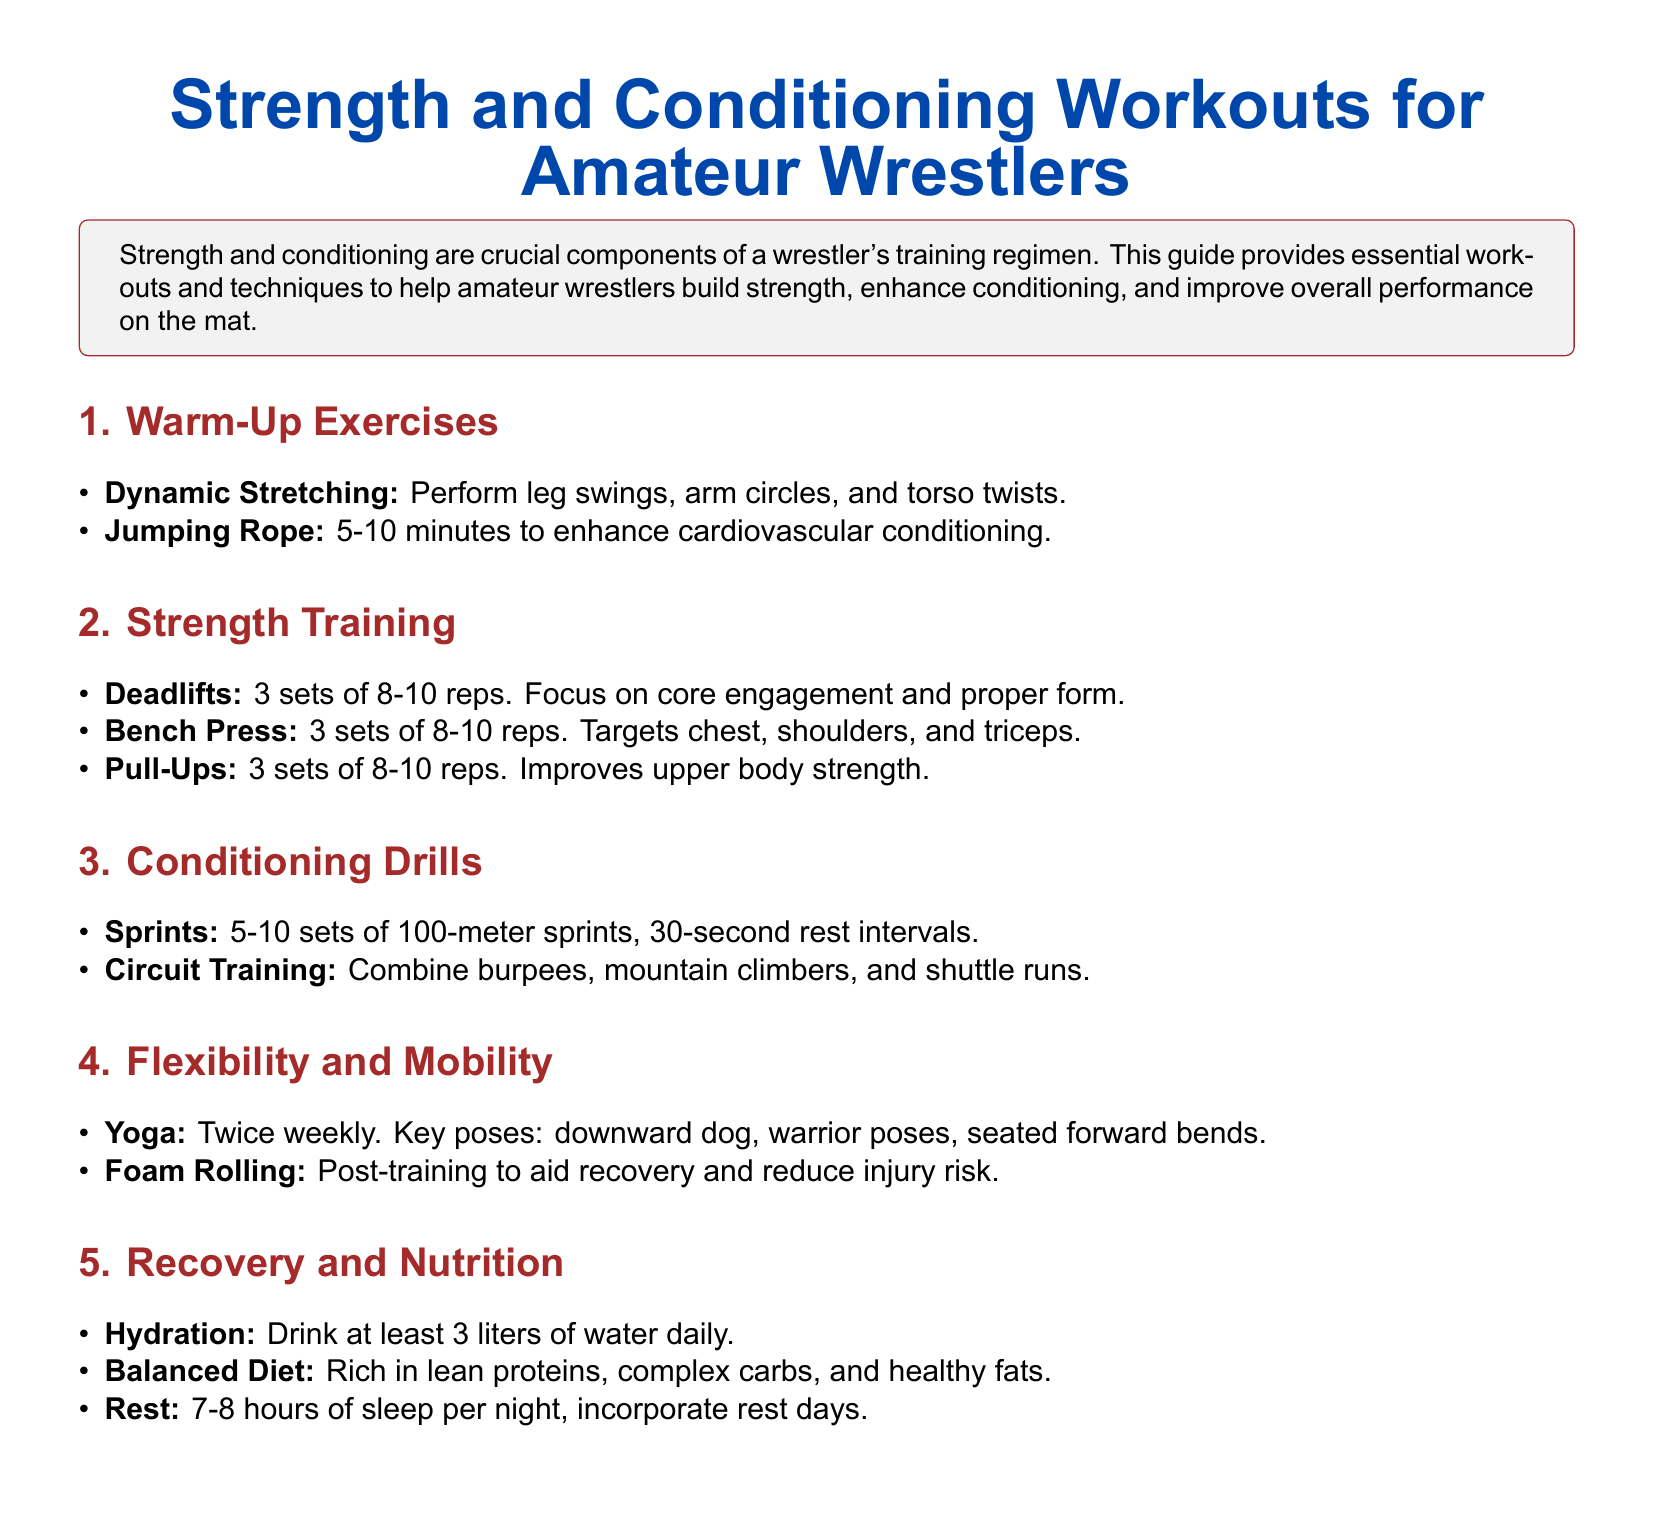What is the focus of warm-up exercises? The document states that warm-up exercises include dynamic stretching and jumping rope, enhancing cardiovascular conditioning and preparing the body for training.
Answer: dynamic stretching, jumping rope How many sets of deadlifts are recommended? The document specifies that the deadlifts exercise includes performing 3 sets of 8-10 reps.
Answer: 3 sets What conditioning drill involves sprints? The document mentions sprints as one of the conditioning drills, specifying sets and rest intervals.
Answer: sprints How often should yoga be performed according to the guide? The document indicates that yoga should be practiced twice weekly.
Answer: twice weekly What is the recommended daily water intake? The document recommends drinking at least 3 liters of water daily for hydration.
Answer: 3 liters Why is foam rolling suggested? The document states that foam rolling is suggested post-training to aid recovery and reduce the risk of injury.
Answer: aid recovery, reduce injury risk What types of foods should be included in a balanced diet? The document outlines that a balanced diet should include lean proteins, complex carbs, and healthy fats.
Answer: lean proteins, complex carbs, healthy fats What is the recommended amount of sleep per night? The document recommends getting 7-8 hours of sleep per night for recovery.
Answer: 7-8 hours 